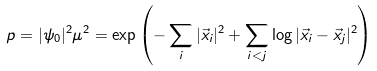<formula> <loc_0><loc_0><loc_500><loc_500>p = | \psi _ { 0 } | ^ { 2 } \mu ^ { 2 } = \exp \left ( - \sum _ { i } | \vec { x } _ { i } | ^ { 2 } + \sum _ { i < j } \log | \vec { x } _ { i } - \vec { x } _ { j } | ^ { 2 } \right )</formula> 